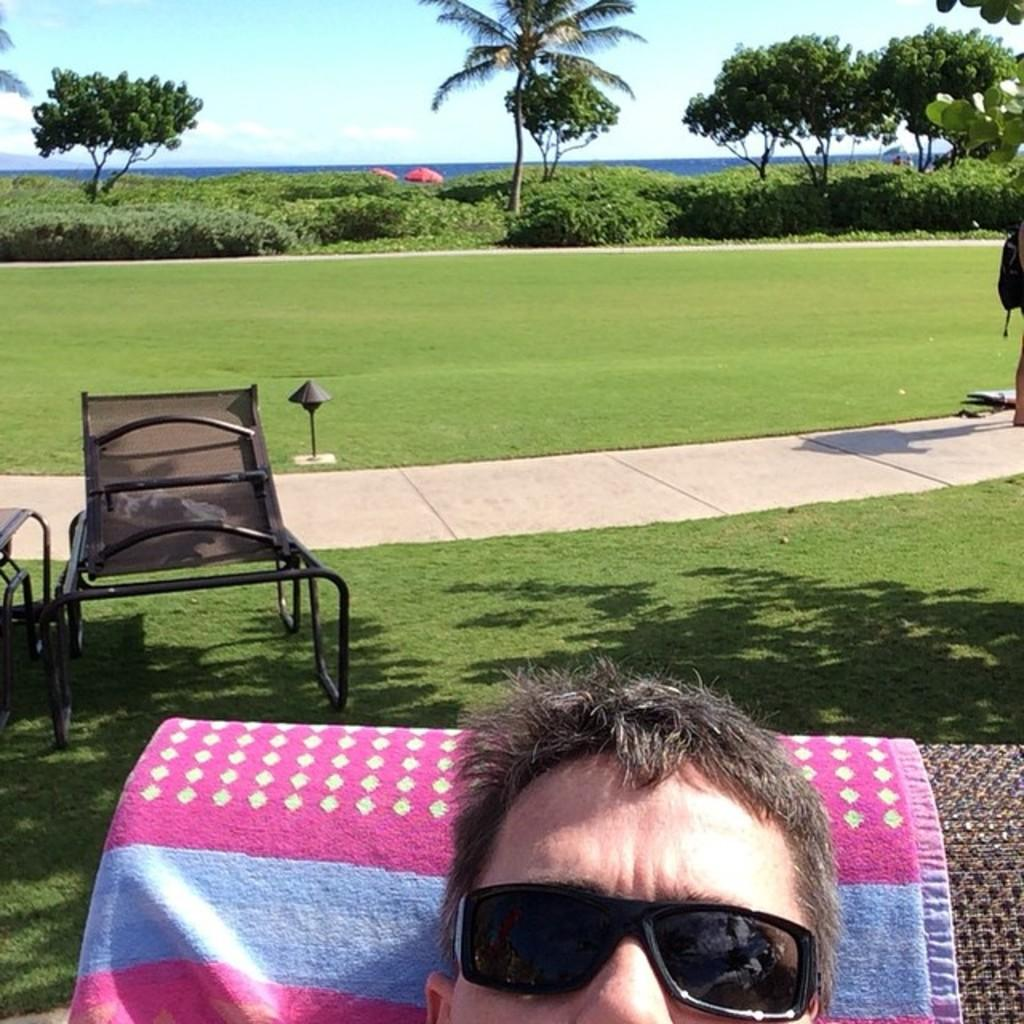Who is present in the image? There is a man in the image. What is the man wearing that is noticeable? The man is wearing black color glasses. What can be seen in the background of the image? There is a path, grass, trees, plants, and the sky visible in the background of the image. Are there any other objects on the ground in the image? Yes, there are other objects on the ground in the image. What is the value of the zoo in the image? There is no zoo present in the image, so it is not possible to determine its value. 